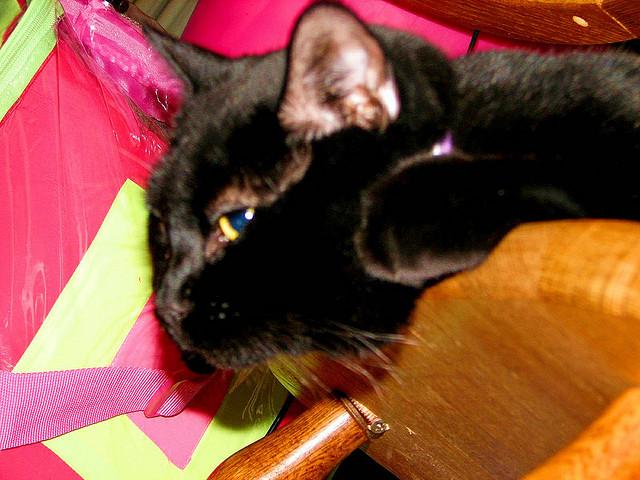What color are the cats eyes?
Short answer required. Blue. Is the cat's eye blue?
Be succinct. Yes. What color is the cat?
Short answer required. Black. 